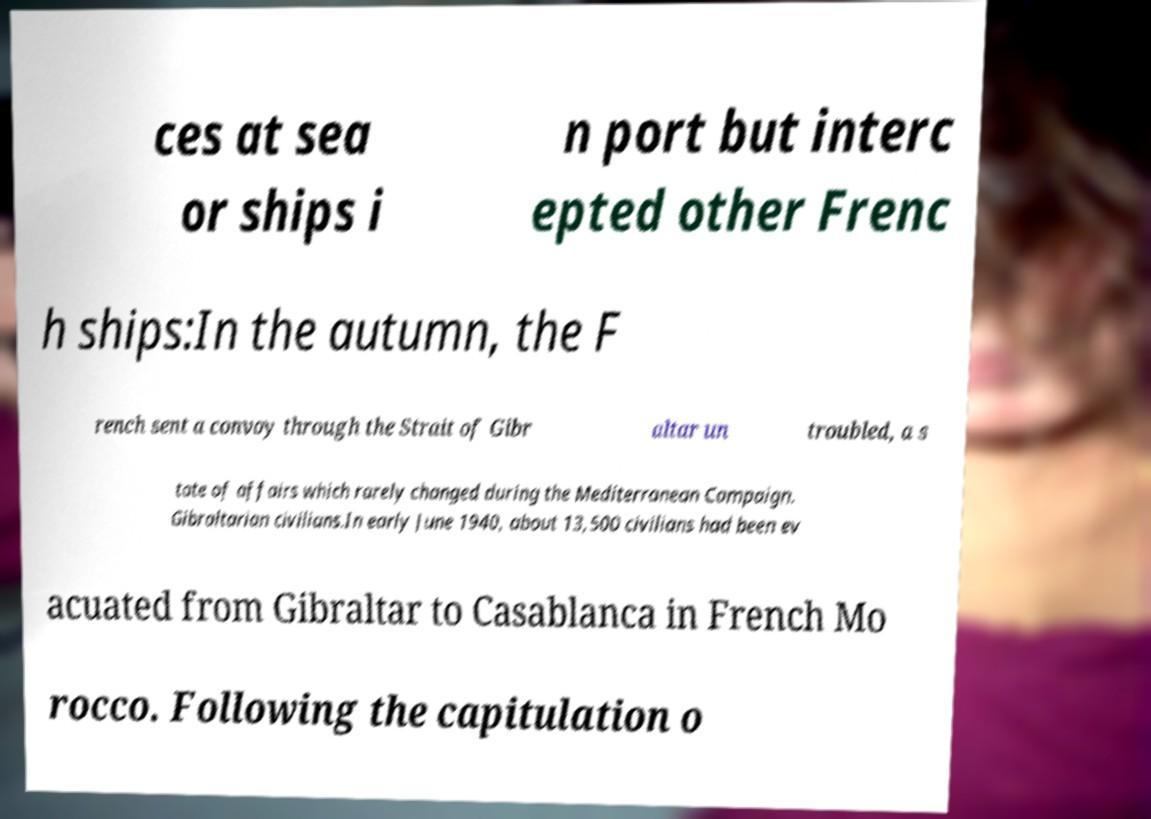Could you assist in decoding the text presented in this image and type it out clearly? ces at sea or ships i n port but interc epted other Frenc h ships:In the autumn, the F rench sent a convoy through the Strait of Gibr altar un troubled, a s tate of affairs which rarely changed during the Mediterranean Campaign. Gibraltarian civilians.In early June 1940, about 13,500 civilians had been ev acuated from Gibraltar to Casablanca in French Mo rocco. Following the capitulation o 